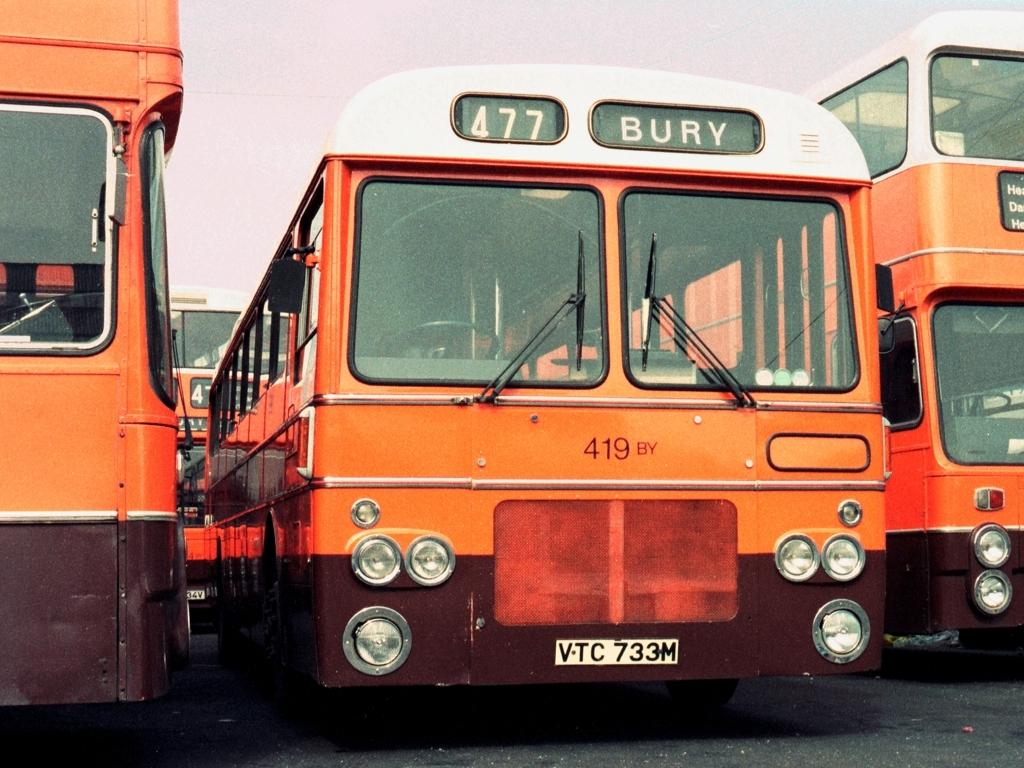What is the significance of 'Bury' written on the bus? 'Bury' written on the bus suggests it is the final destination on the route that the bus serves. Bury is a town and it would be a part of the public transit route indicated by the number '477'. 